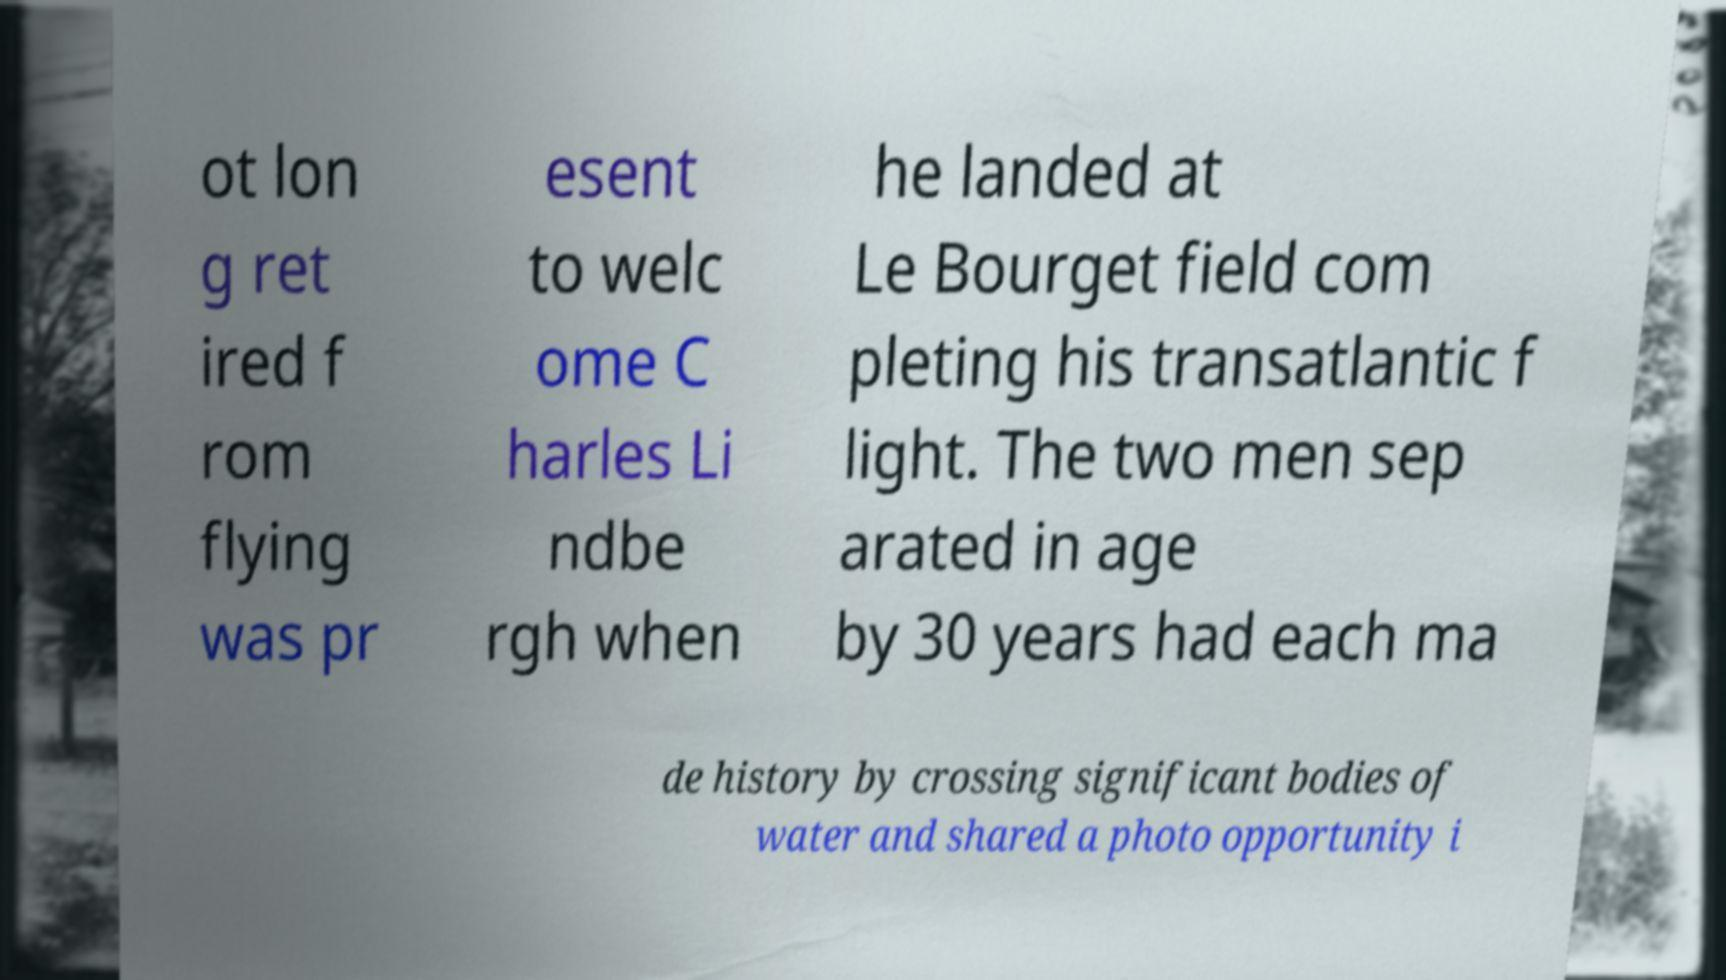What messages or text are displayed in this image? I need them in a readable, typed format. ot lon g ret ired f rom flying was pr esent to welc ome C harles Li ndbe rgh when he landed at Le Bourget field com pleting his transatlantic f light. The two men sep arated in age by 30 years had each ma de history by crossing significant bodies of water and shared a photo opportunity i 